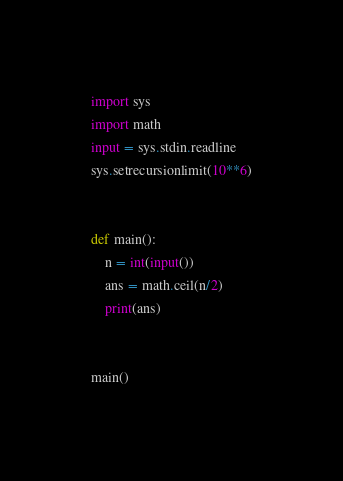Convert code to text. <code><loc_0><loc_0><loc_500><loc_500><_Python_>import sys
import math
input = sys.stdin.readline
sys.setrecursionlimit(10**6)


def main():
    n = int(input())
    ans = math.ceil(n/2)
    print(ans)


main()
</code> 